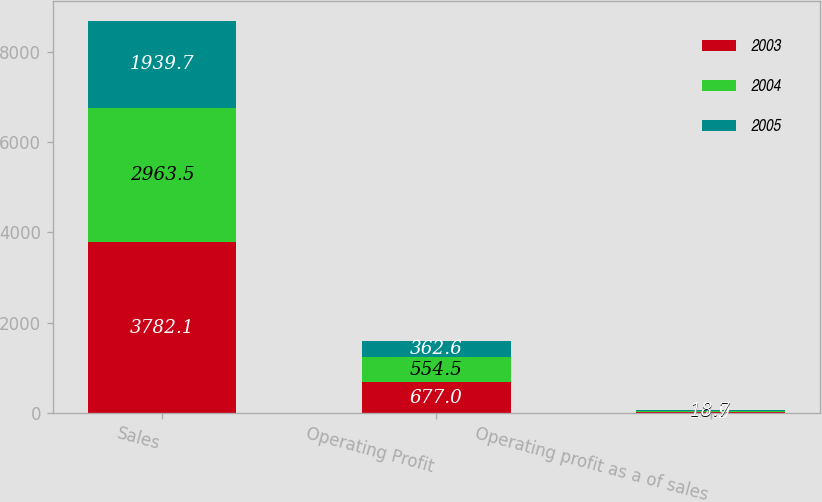Convert chart to OTSL. <chart><loc_0><loc_0><loc_500><loc_500><stacked_bar_chart><ecel><fcel>Sales<fcel>Operating Profit<fcel>Operating profit as a of sales<nl><fcel>2003<fcel>3782.1<fcel>677<fcel>17.9<nl><fcel>2004<fcel>2963.5<fcel>554.5<fcel>18.7<nl><fcel>2005<fcel>1939.7<fcel>362.6<fcel>18.7<nl></chart> 